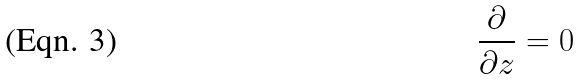<formula> <loc_0><loc_0><loc_500><loc_500>\frac { \partial } { \partial z } = 0</formula> 